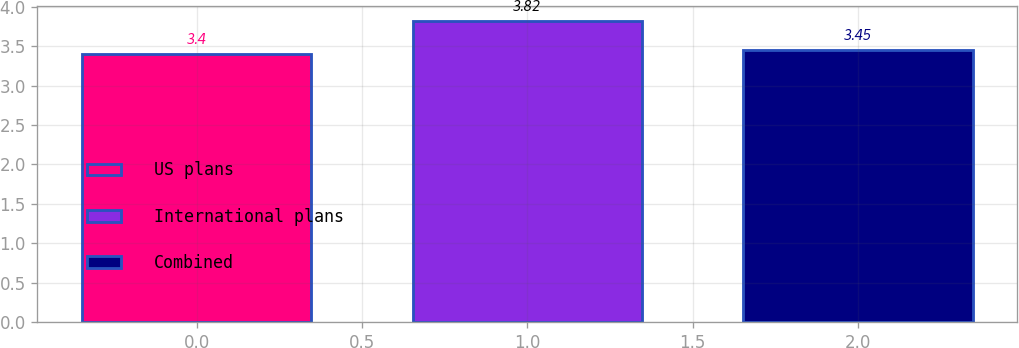Convert chart to OTSL. <chart><loc_0><loc_0><loc_500><loc_500><bar_chart><fcel>US plans<fcel>International plans<fcel>Combined<nl><fcel>3.4<fcel>3.82<fcel>3.45<nl></chart> 